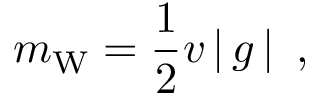Convert formula to latex. <formula><loc_0><loc_0><loc_500><loc_500>m _ { W } = { \frac { 1 } { 2 } } v \left | \, g \, \right | \ ,</formula> 